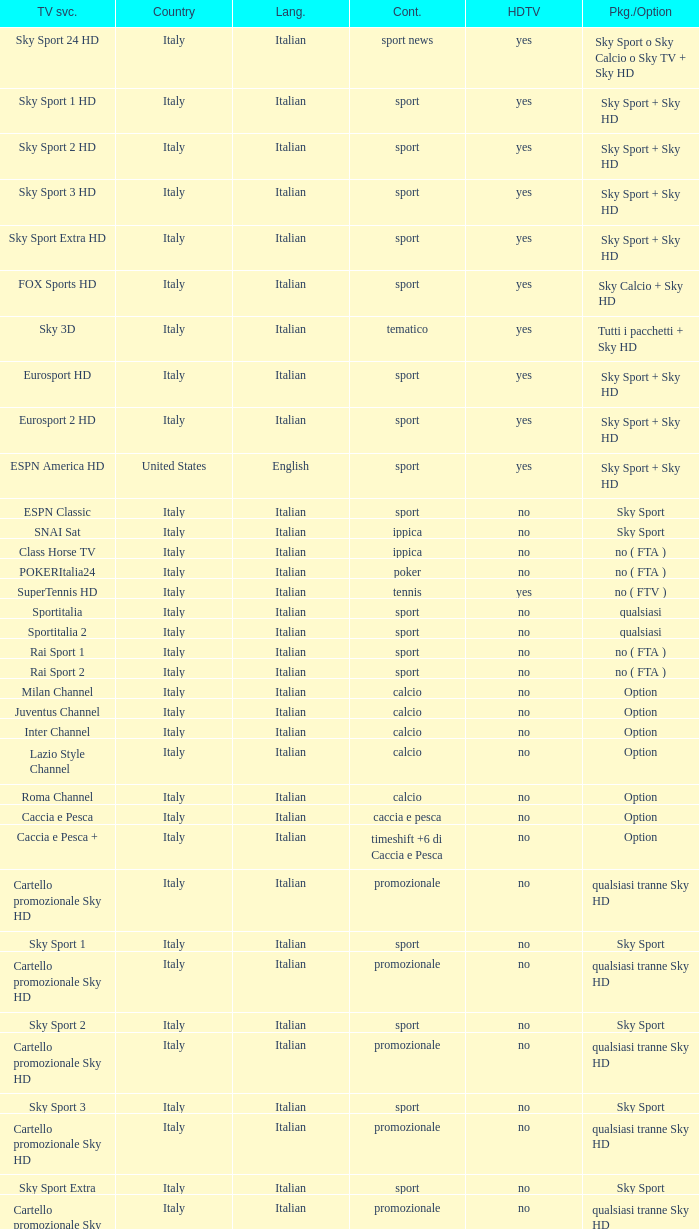What is Television Service, when Content is Calcio, and when Package/Option is Option? Milan Channel, Juventus Channel, Inter Channel, Lazio Style Channel, Roma Channel. 